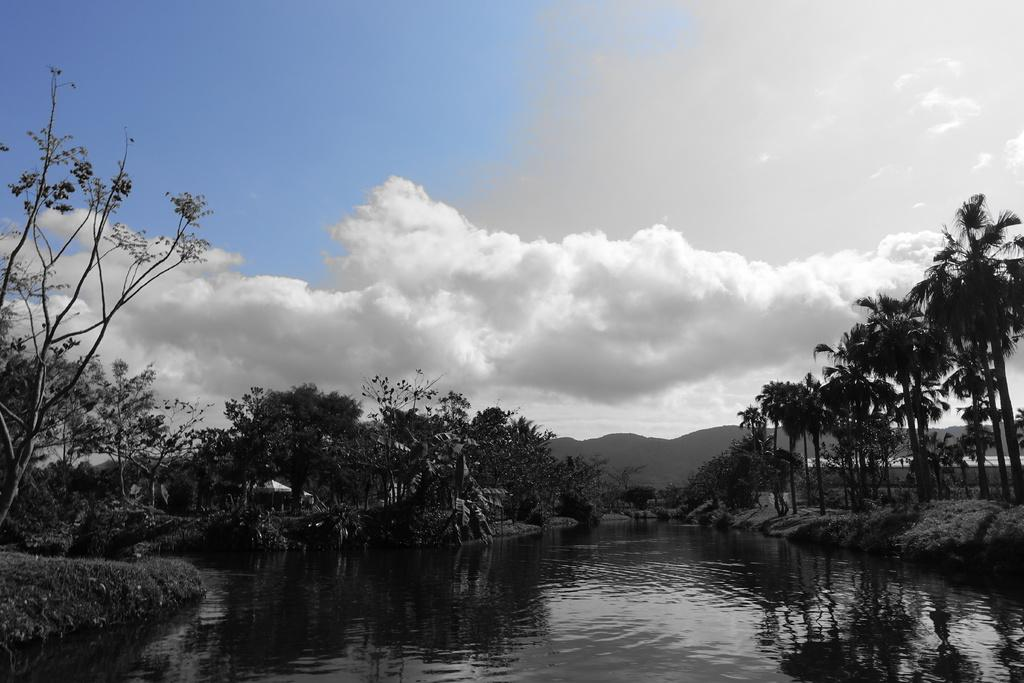What is the primary element visible in the image? There is water in the image. What type of landscape features can be seen in the image? There are hills, trees, and grass visible in the image. What is visible in the background of the image? The sky is visible in the background of the image. Who is the owner of the pump in the image? There is no pump present in the image. Can you see any caves in the image? There are no caves visible in the image. 